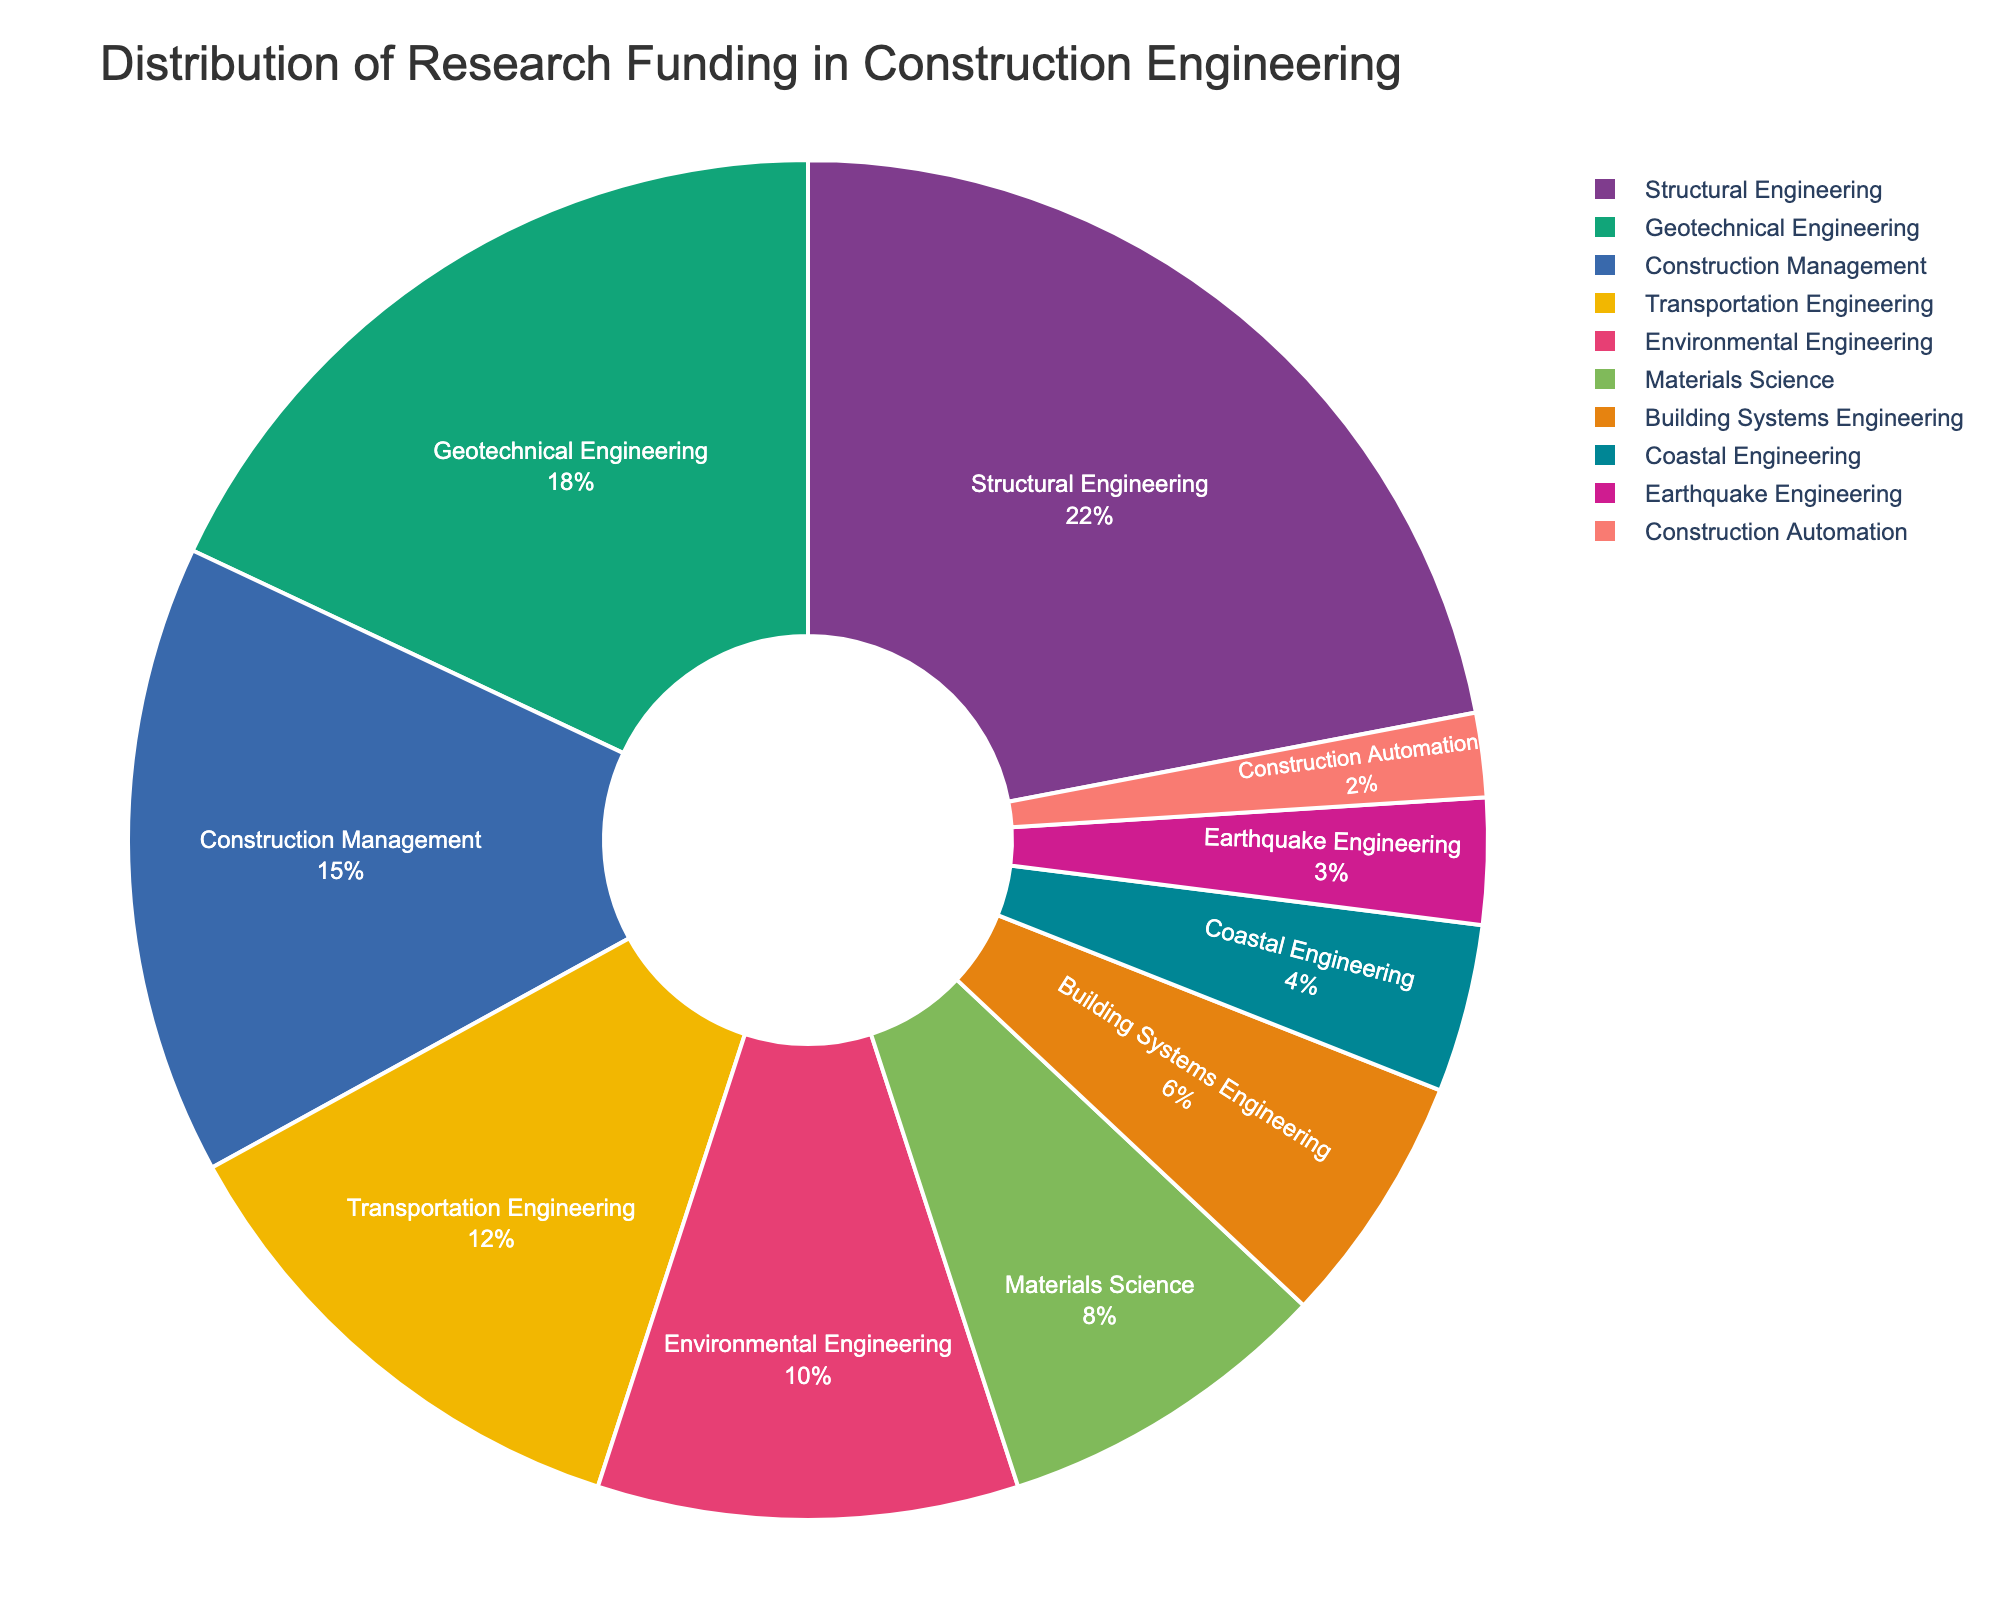What is the discipline with the highest research funding percentage? By observing the pie chart, the discipline with the largest slice represents the highest funding percentage.
Answer: Structural Engineering Which disciplines receive less than 10% of the total research funding each? Look at the labeled percentages on the pie chart and identify those below 10%.
Answer: Materials Science, Building Systems Engineering, Coastal Engineering, Earthquake Engineering, Construction Automation What is the combined funding percentage of Geotechnical Engineering, Transportation Engineering, and Environmental Engineering? Add the individual percentages as shown on the pie chart: 18% (Geotechnical) + 12% (Transportation) + 10% (Environmental).
Answer: 40% How much more funding does Structural Engineering receive compared to Earthquake Engineering? Subtract the funding percentage of Earthquake Engineering from Structural Engineering. 22% (Structural) - 3% (Earthquake).
Answer: 19% Which discipline has the smallest funding allocation and what percentage is it? Identify the smallest slice on the pie chart and read its label.
Answer: Construction Automation, 2% Are there more disciplines receiving above or below the median funding percentage of the provided disciplines? List the funding percentages and find the median, then count how many are above and how many are below. Median is 9% (between Environmental and Materials Science). Above: 5 disciplines (Structural, Geotechnical, Construction Management, Transportation, Environmental); Below: 5 disciplines (Materials Science, Building Systems, Coastal, Earthquake, Construction Automation).
Answer: Equal What is the total percentage of research funding allocated to disciplines categorized under "Engineering"? Sum the percentages of all items, as all are types of engineering.
Answer: 100% Between Environmental Engineering and Transportation Engineering, which receives more funding and by how much? Compare their percentages as shown in the pie chart: Transportation is 12%, Environmental is 10%. Thus, Transportation - Environmental.
Answer: Transportation by 2% Which discipline has a funding percentage closest to the average funding percentage? First, calculate the average funding percentage: sum all percentages and divide by the number of disciplines (100% / 10). Identify the discipline closest to this average.
Answer: Materials Science (Average is 10%) What two disciplines combined make up 30% of the total research funding? Find pairs of disciplines whose funding percentages sum to 30%. Building Systems Engineering (6%) + Structural Engineering (22%)
Answer: Structural Engineering and Building Systems Engineering 